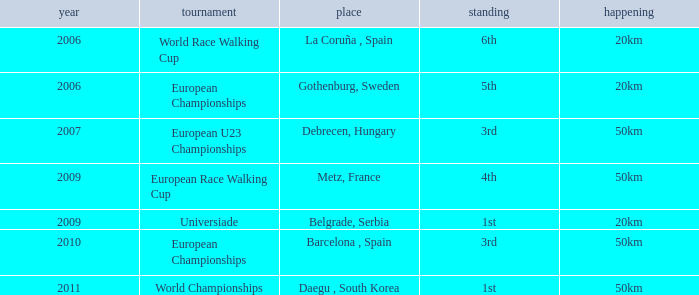Which Event has 5th Position in the European Championships Competition? 20km. Could you parse the entire table? {'header': ['year', 'tournament', 'place', 'standing', 'happening'], 'rows': [['2006', 'World Race Walking Cup', 'La Coruña , Spain', '6th', '20km'], ['2006', 'European Championships', 'Gothenburg, Sweden', '5th', '20km'], ['2007', 'European U23 Championships', 'Debrecen, Hungary', '3rd', '50km'], ['2009', 'European Race Walking Cup', 'Metz, France', '4th', '50km'], ['2009', 'Universiade', 'Belgrade, Serbia', '1st', '20km'], ['2010', 'European Championships', 'Barcelona , Spain', '3rd', '50km'], ['2011', 'World Championships', 'Daegu , South Korea', '1st', '50km']]} 